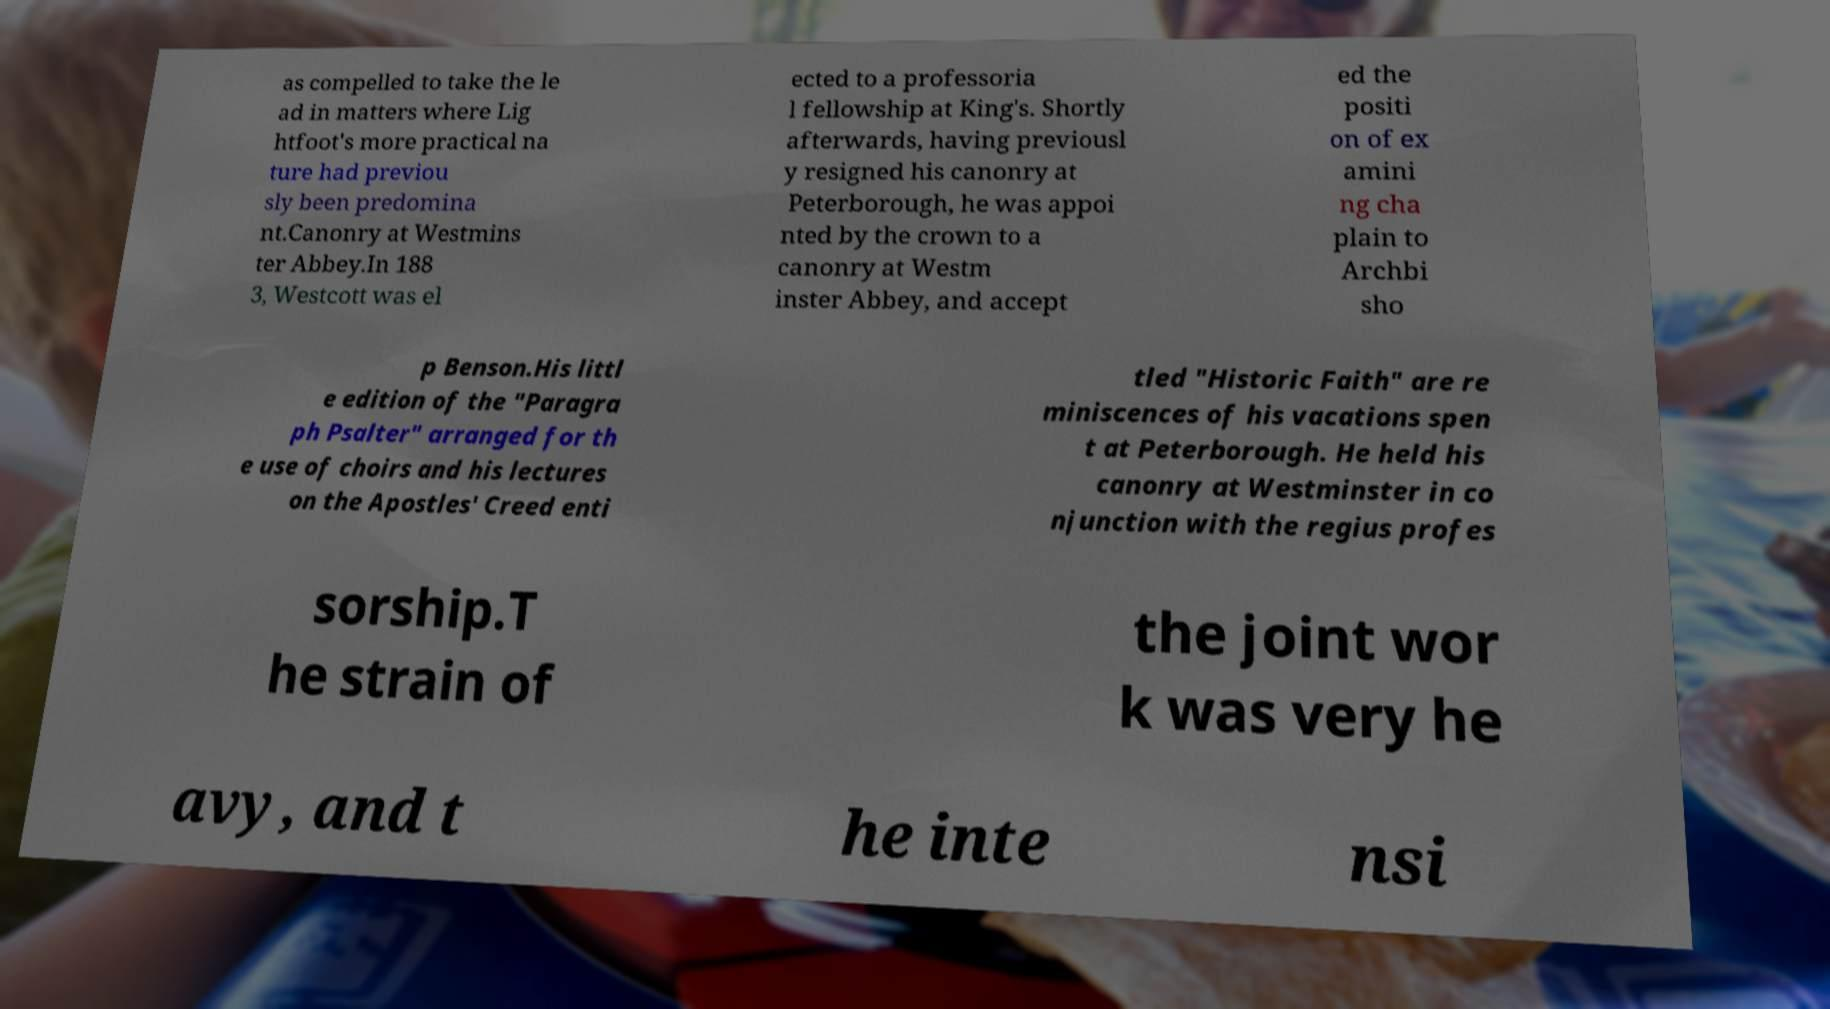Could you assist in decoding the text presented in this image and type it out clearly? as compelled to take the le ad in matters where Lig htfoot's more practical na ture had previou sly been predomina nt.Canonry at Westmins ter Abbey.In 188 3, Westcott was el ected to a professoria l fellowship at King's. Shortly afterwards, having previousl y resigned his canonry at Peterborough, he was appoi nted by the crown to a canonry at Westm inster Abbey, and accept ed the positi on of ex amini ng cha plain to Archbi sho p Benson.His littl e edition of the "Paragra ph Psalter" arranged for th e use of choirs and his lectures on the Apostles' Creed enti tled "Historic Faith" are re miniscences of his vacations spen t at Peterborough. He held his canonry at Westminster in co njunction with the regius profes sorship.T he strain of the joint wor k was very he avy, and t he inte nsi 